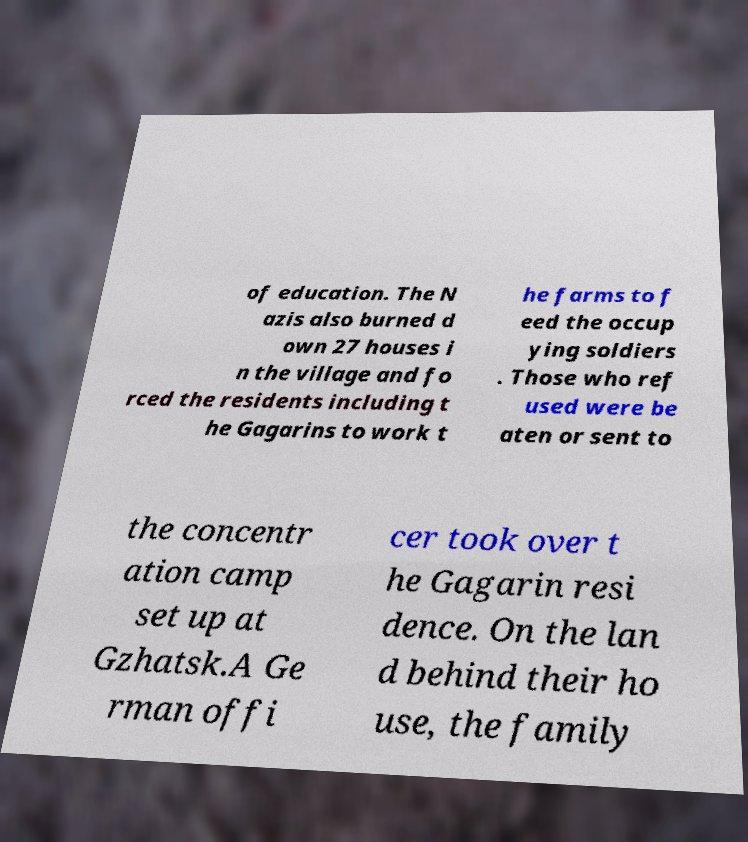There's text embedded in this image that I need extracted. Can you transcribe it verbatim? of education. The N azis also burned d own 27 houses i n the village and fo rced the residents including t he Gagarins to work t he farms to f eed the occup ying soldiers . Those who ref used were be aten or sent to the concentr ation camp set up at Gzhatsk.A Ge rman offi cer took over t he Gagarin resi dence. On the lan d behind their ho use, the family 